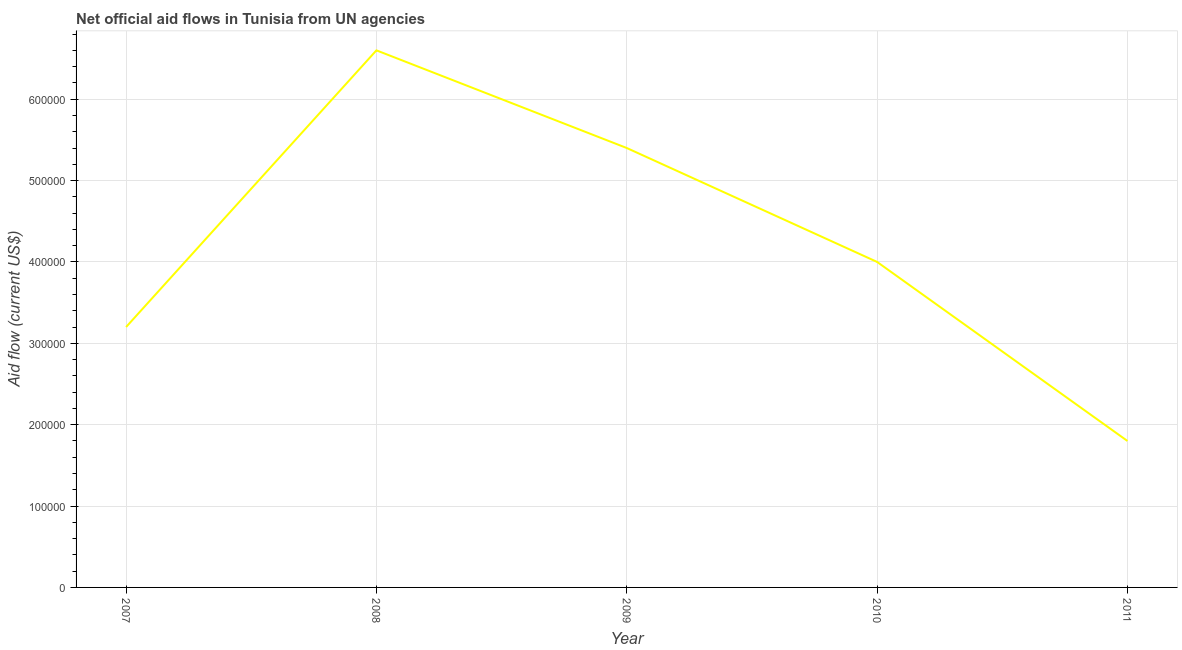What is the net official flows from un agencies in 2008?
Your answer should be very brief. 6.60e+05. Across all years, what is the maximum net official flows from un agencies?
Provide a succinct answer. 6.60e+05. Across all years, what is the minimum net official flows from un agencies?
Ensure brevity in your answer.  1.80e+05. In which year was the net official flows from un agencies maximum?
Offer a very short reply. 2008. What is the sum of the net official flows from un agencies?
Provide a short and direct response. 2.10e+06. What is the difference between the net official flows from un agencies in 2008 and 2009?
Provide a succinct answer. 1.20e+05. What is the ratio of the net official flows from un agencies in 2010 to that in 2011?
Offer a very short reply. 2.22. What is the difference between the highest and the lowest net official flows from un agencies?
Provide a short and direct response. 4.80e+05. In how many years, is the net official flows from un agencies greater than the average net official flows from un agencies taken over all years?
Give a very brief answer. 2. Does the net official flows from un agencies monotonically increase over the years?
Your answer should be compact. No. What is the difference between two consecutive major ticks on the Y-axis?
Offer a terse response. 1.00e+05. Are the values on the major ticks of Y-axis written in scientific E-notation?
Offer a terse response. No. Does the graph contain any zero values?
Offer a very short reply. No. What is the title of the graph?
Your answer should be compact. Net official aid flows in Tunisia from UN agencies. What is the label or title of the X-axis?
Keep it short and to the point. Year. What is the label or title of the Y-axis?
Offer a very short reply. Aid flow (current US$). What is the Aid flow (current US$) in 2008?
Your answer should be very brief. 6.60e+05. What is the Aid flow (current US$) of 2009?
Make the answer very short. 5.40e+05. What is the Aid flow (current US$) of 2010?
Offer a terse response. 4.00e+05. What is the difference between the Aid flow (current US$) in 2007 and 2008?
Provide a short and direct response. -3.40e+05. What is the difference between the Aid flow (current US$) in 2007 and 2010?
Offer a terse response. -8.00e+04. What is the difference between the Aid flow (current US$) in 2008 and 2009?
Keep it short and to the point. 1.20e+05. What is the difference between the Aid flow (current US$) in 2009 and 2010?
Make the answer very short. 1.40e+05. What is the difference between the Aid flow (current US$) in 2010 and 2011?
Ensure brevity in your answer.  2.20e+05. What is the ratio of the Aid flow (current US$) in 2007 to that in 2008?
Ensure brevity in your answer.  0.48. What is the ratio of the Aid flow (current US$) in 2007 to that in 2009?
Provide a short and direct response. 0.59. What is the ratio of the Aid flow (current US$) in 2007 to that in 2011?
Offer a very short reply. 1.78. What is the ratio of the Aid flow (current US$) in 2008 to that in 2009?
Your answer should be very brief. 1.22. What is the ratio of the Aid flow (current US$) in 2008 to that in 2010?
Offer a terse response. 1.65. What is the ratio of the Aid flow (current US$) in 2008 to that in 2011?
Provide a succinct answer. 3.67. What is the ratio of the Aid flow (current US$) in 2009 to that in 2010?
Offer a terse response. 1.35. What is the ratio of the Aid flow (current US$) in 2010 to that in 2011?
Offer a terse response. 2.22. 